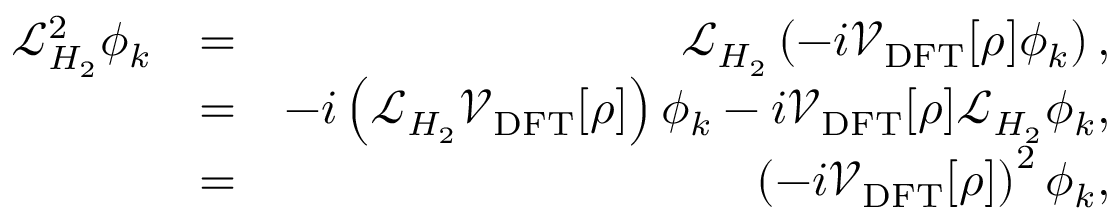<formula> <loc_0><loc_0><loc_500><loc_500>\begin{array} { r l r } { \mathcal { L } _ { H _ { 2 } } ^ { 2 } \phi _ { k } } & { = } & { \mathcal { L } _ { H _ { 2 } } \left ( - i \mathcal { V } _ { D F T } [ \rho ] \phi _ { k } \right ) , } \\ & { = } & { - i \left ( \mathcal { L } _ { H _ { 2 } } \mathcal { V } _ { D F T } [ \rho ] \right ) \phi _ { k } - i \mathcal { V } _ { D F T } [ \rho ] \mathcal { L } _ { H _ { 2 } } \phi _ { k } , } \\ & { = } & { \left ( - i \mathcal { V } _ { D F T } [ \rho ] \right ) ^ { 2 } \phi _ { k } , } \end{array}</formula> 